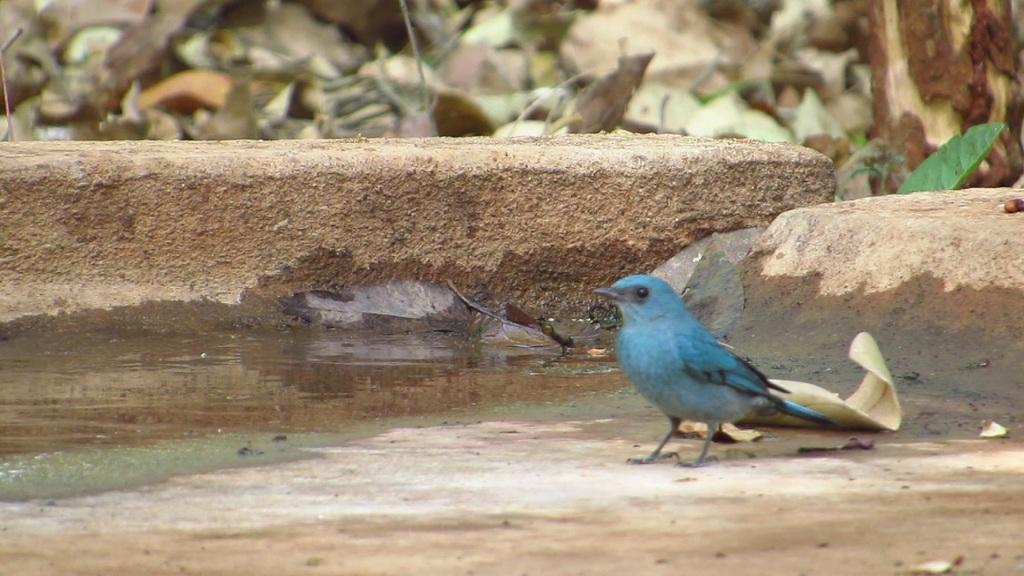Please provide a concise description of this image. In this image I can see the bird in green color. In the background I can see few dried leaves and I can also see the water. 